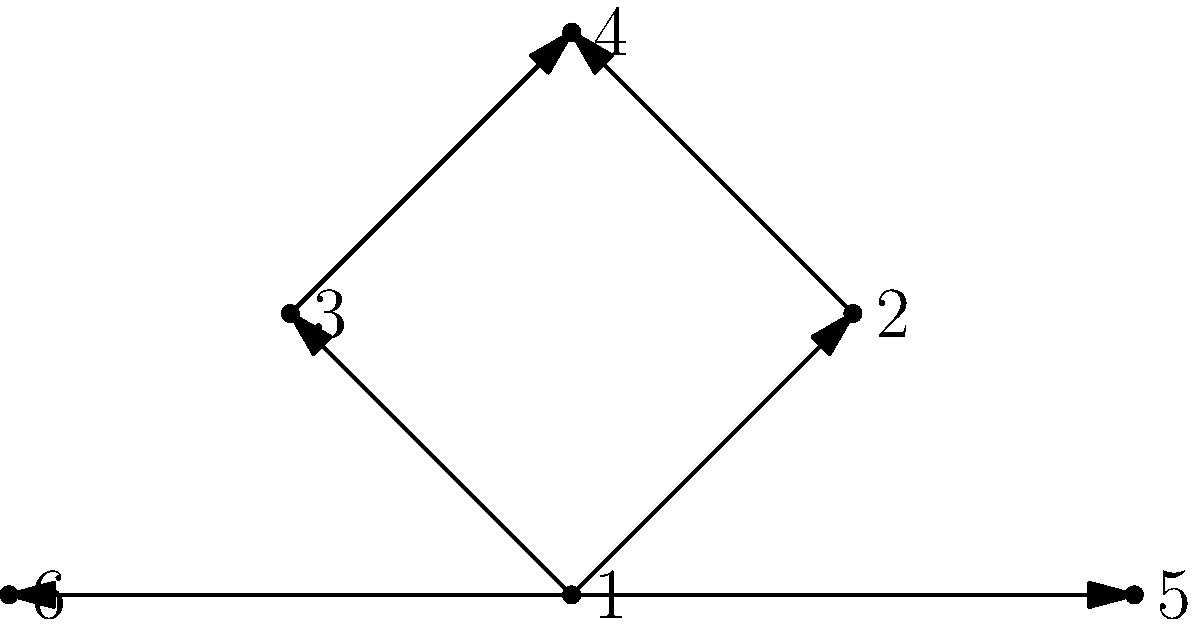In the disease transmission network shown above, each node represents an individual, and arrows indicate the direction of disease transmission. Calculate the out-degree centrality for node 1 (the central node). What does this value suggest about the individual represented by node 1 in the context of disease spread? To solve this problem, we need to follow these steps:

1. Understand out-degree centrality:
   Out-degree centrality is the number of outgoing connections from a node in a directed graph.

2. Count the outgoing connections from node 1:
   - Node 1 has an outgoing connection to node 2
   - Node 1 has an outgoing connection to node 3
   - Node 1 has an outgoing connection to node 5
   - Node 1 has an outgoing connection to node 6

3. Calculate the out-degree centrality:
   Out-degree centrality of node 1 = 4

4. Interpret the result:
   An out-degree centrality of 4 suggests that the individual represented by node 1 has directly transmitted the disease to 4 other individuals. This indicates that node 1 is a significant spreader in this network, potentially representing a superspreader or an individual with high contact rates.

In the context of disease spread, this high out-degree centrality implies that focusing interventions or control measures on this individual could have a substantial impact on reducing disease transmission in the network.
Answer: 4; indicates a significant disease spreader 